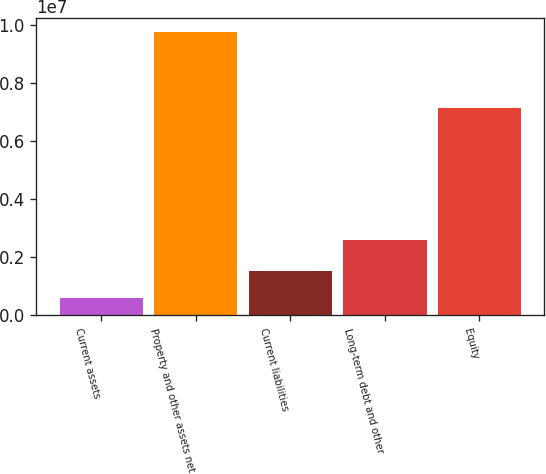Convert chart. <chart><loc_0><loc_0><loc_500><loc_500><bar_chart><fcel>Current assets<fcel>Property and other assets net<fcel>Current liabilities<fcel>Long-term debt and other<fcel>Equity<nl><fcel>614474<fcel>9.75425e+06<fcel>1.52845e+06<fcel>2.60463e+06<fcel>7.13649e+06<nl></chart> 